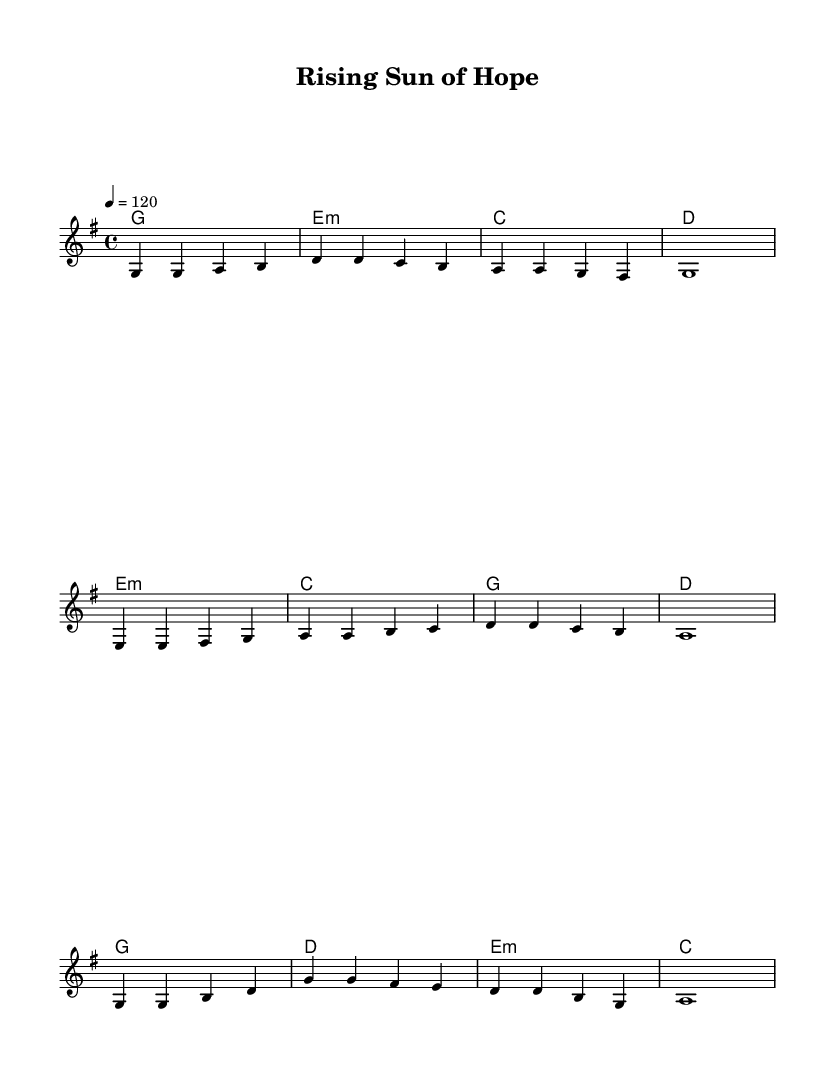What is the key signature of this music? The key signature is G major, which has one sharp (F#).
Answer: G major What is the time signature of the piece? The time signature is 4/4, indicating four beats per measure with a quarter note receiving one beat.
Answer: 4/4 What is the tempo marking of the music? The tempo marking is quarter note = 120, meaning each quarter note is played at a speed of 120 beats per minute.
Answer: 120 How many measures are in the chorus section? The chorus section has four measures, as indicated by the corresponding musical notation in the music sheet.
Answer: 4 What chord is played during the pre-chorus? The primary chord in the pre-chorus is E minor, which is noted during the first measure of the pre-chorus section.
Answer: E minor What is a common theme represented in this piece? The common theme in this piece is hope and resilience, which aligns with the inspirational nature of K-Pop anthems.
Answer: Hope and resilience Which musical section contains the highest note? The highest note in the melody is B, which appears in the verse and pre-chorus sections.
Answer: B 